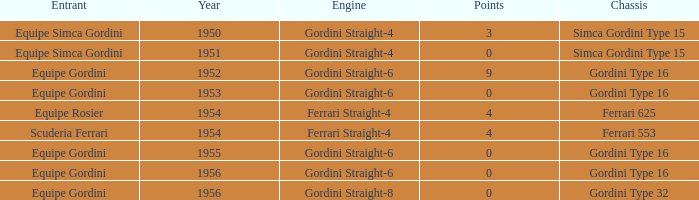What engine was used by Equipe Simca Gordini before 1956 with less than 4 points? Gordini Straight-4, Gordini Straight-4. 